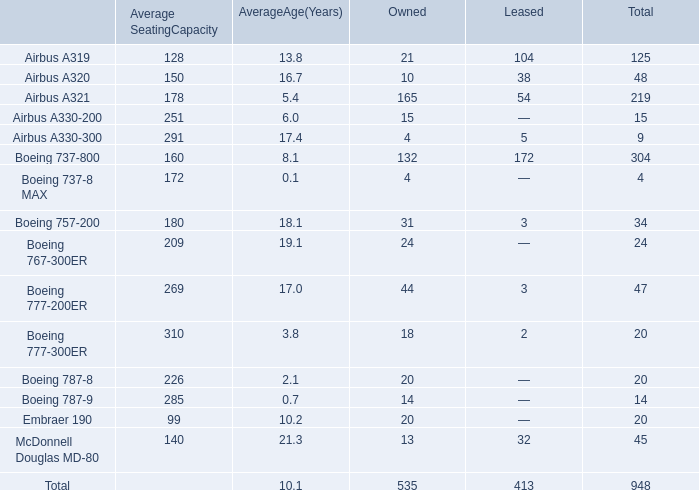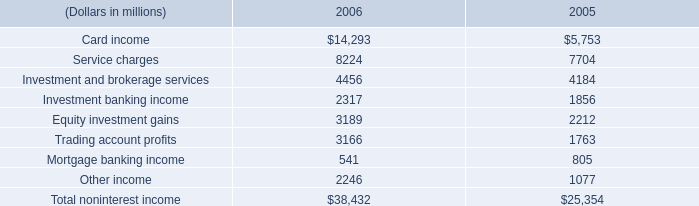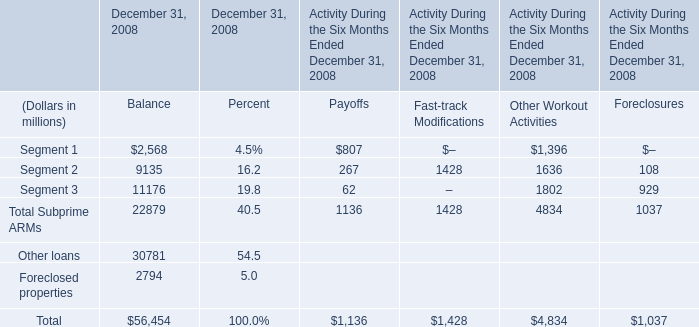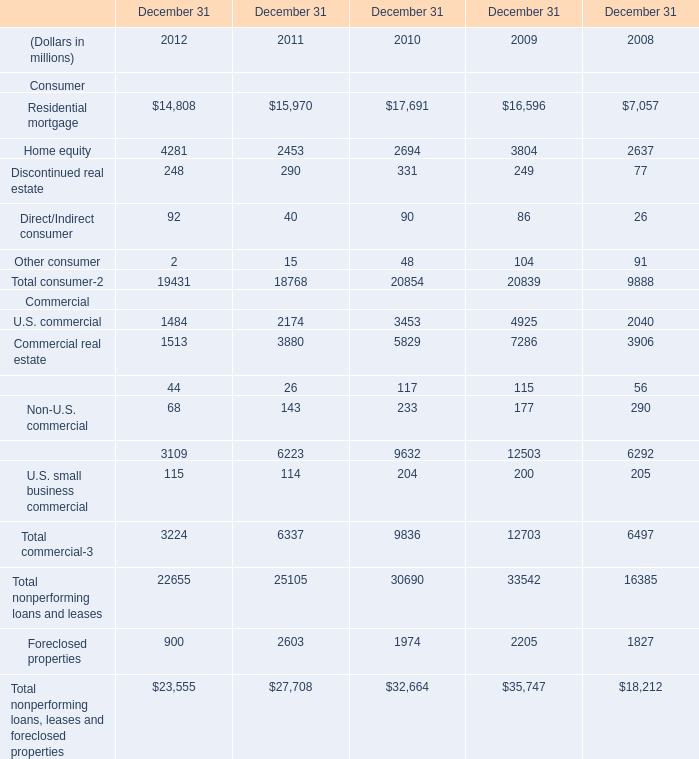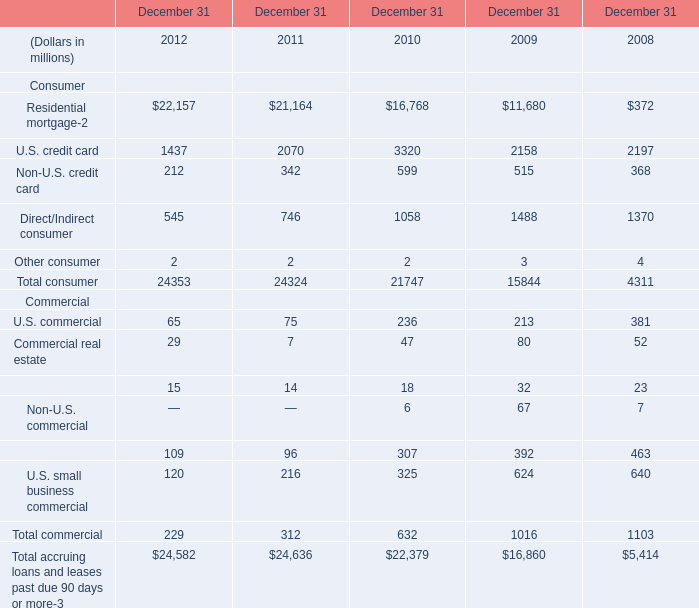What's the sum of Residential mortgage of December 31 2011, U.S. commercial Commercial of December 31 2009, and Total commercial Commercial of December 31 2008 ? 
Computations: ((21164.0 + 4925.0) + 6497.0)
Answer: 32586.0. 